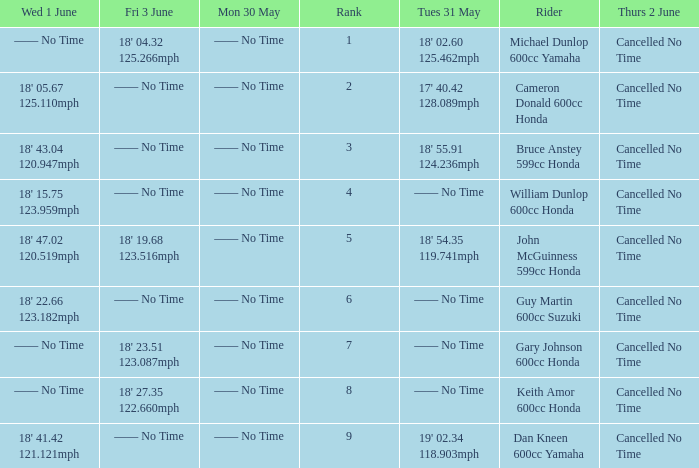What is the Fri 3 June time for the rider with a Weds 1 June time of 18' 22.66 123.182mph? —— No Time. 